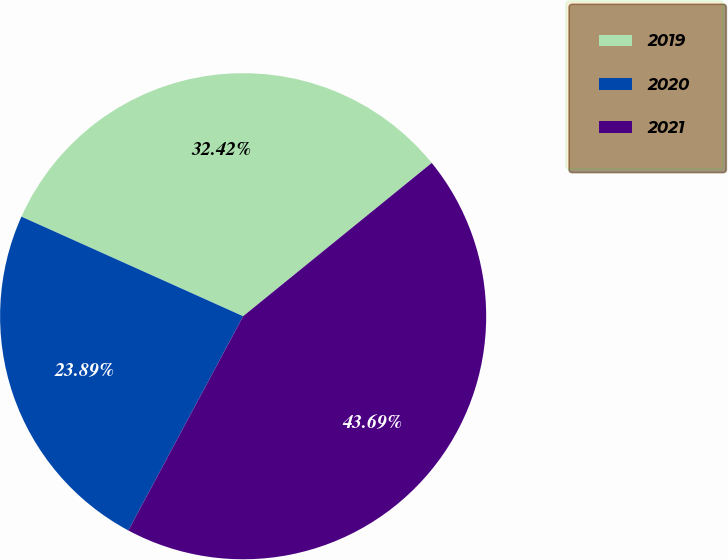<chart> <loc_0><loc_0><loc_500><loc_500><pie_chart><fcel>2019<fcel>2020<fcel>2021<nl><fcel>32.42%<fcel>23.89%<fcel>43.69%<nl></chart> 